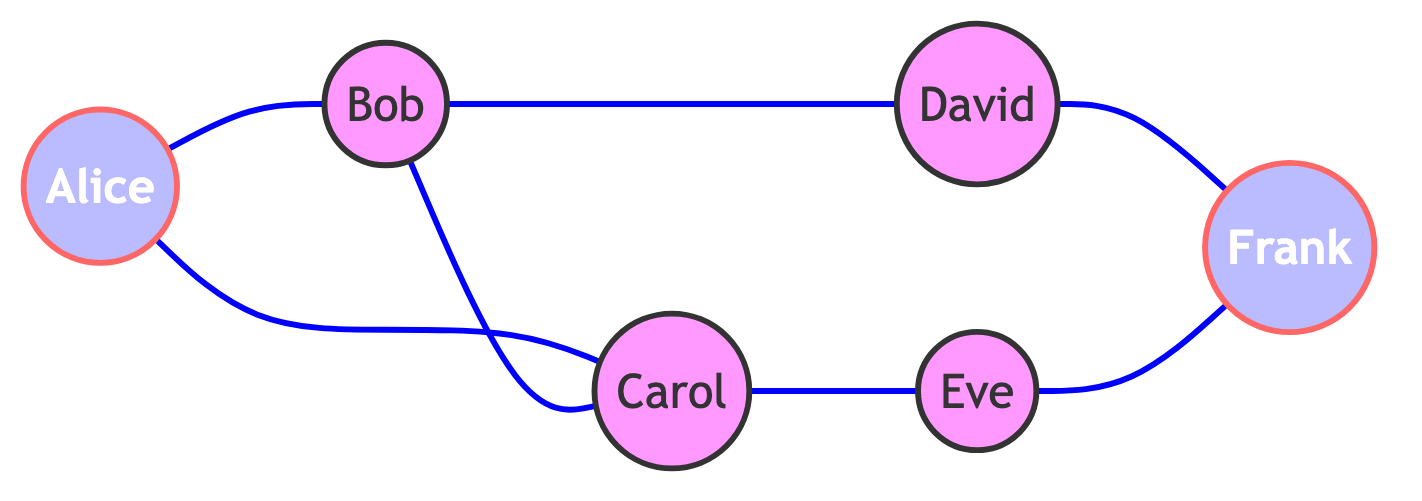What is the total number of nodes in the graph? The graph contains six individuals: Alice, Bob, Carol, David, Eve, and Frank. By counting each person listed in the nodes section, we find that the total is 6.
Answer: 6 Who is connected to Bob? Bob is connected to Alice, Carol, and David, as indicated by the edges linked to Bob. By visually tracing the connections from Bob, we can see these three individuals directly connected to him.
Answer: Alice, Carol, David How many edges are there in total? The graph contains six edges that represent the connections between individuals. By counting each connection listed in the edges section, we find that the total is 6.
Answer: 6 Which two individuals are friends through Carol? Alice and Bob are friends through their mutual connection with Carol. Both Alice and Bob have direct edges to Carol, demonstrating they are connected through her.
Answer: Alice, Bob Who has a direct connection to Frank? David and Eve have direct connections to Frank, as indicated by the edges that lead from both David and Eve to Frank. Tracing these edges shows that Frank is linked to both individuals directly.
Answer: David, Eve Is there a path from Alice to Frank? Yes, there is a path from Alice to Frank through a series of connections: Alice to Bob, Bob to Carol, Carol to Eve, and finally Eve to Frank. By following these edges, we can see the entire route from Alice to Frank.
Answer: Yes Which node has the most connections? Bob has the most connections, totaling three edges leading to Alice, Carol, and David. By counting the direct connections from each node, Bob’s connections outnumber those of the other individuals.
Answer: Bob What type of graph is this? This is an undirected graph, as shown by the edges which do not have a direction and signify mutual friendships or connections between individuals. In undirected graphs, connections can be traversed in any direction.
Answer: Undirected graph How many connections does Eve have? Eve has two connections, one with Carol and the other with Frank. By examining the edges leading to Eve, it is clear she is connected to these two individuals only.
Answer: 2 